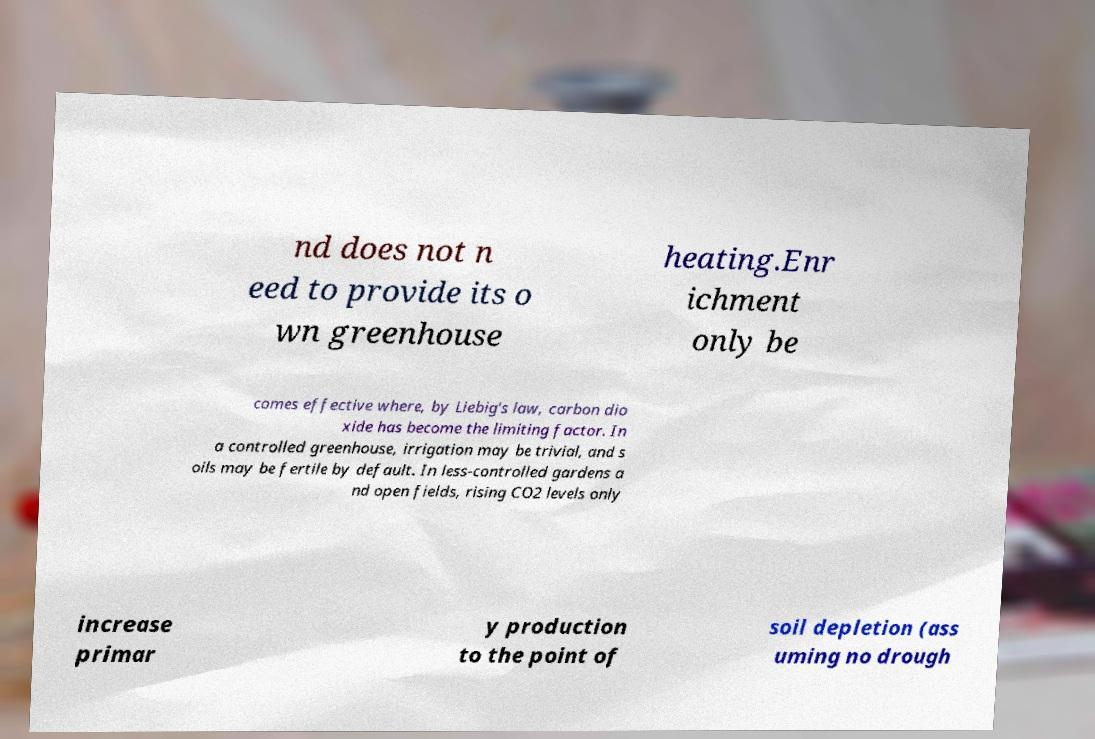For documentation purposes, I need the text within this image transcribed. Could you provide that? nd does not n eed to provide its o wn greenhouse heating.Enr ichment only be comes effective where, by Liebig's law, carbon dio xide has become the limiting factor. In a controlled greenhouse, irrigation may be trivial, and s oils may be fertile by default. In less-controlled gardens a nd open fields, rising CO2 levels only increase primar y production to the point of soil depletion (ass uming no drough 